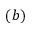<formula> <loc_0><loc_0><loc_500><loc_500>( b )</formula> 